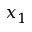Convert formula to latex. <formula><loc_0><loc_0><loc_500><loc_500>x _ { 1 }</formula> 